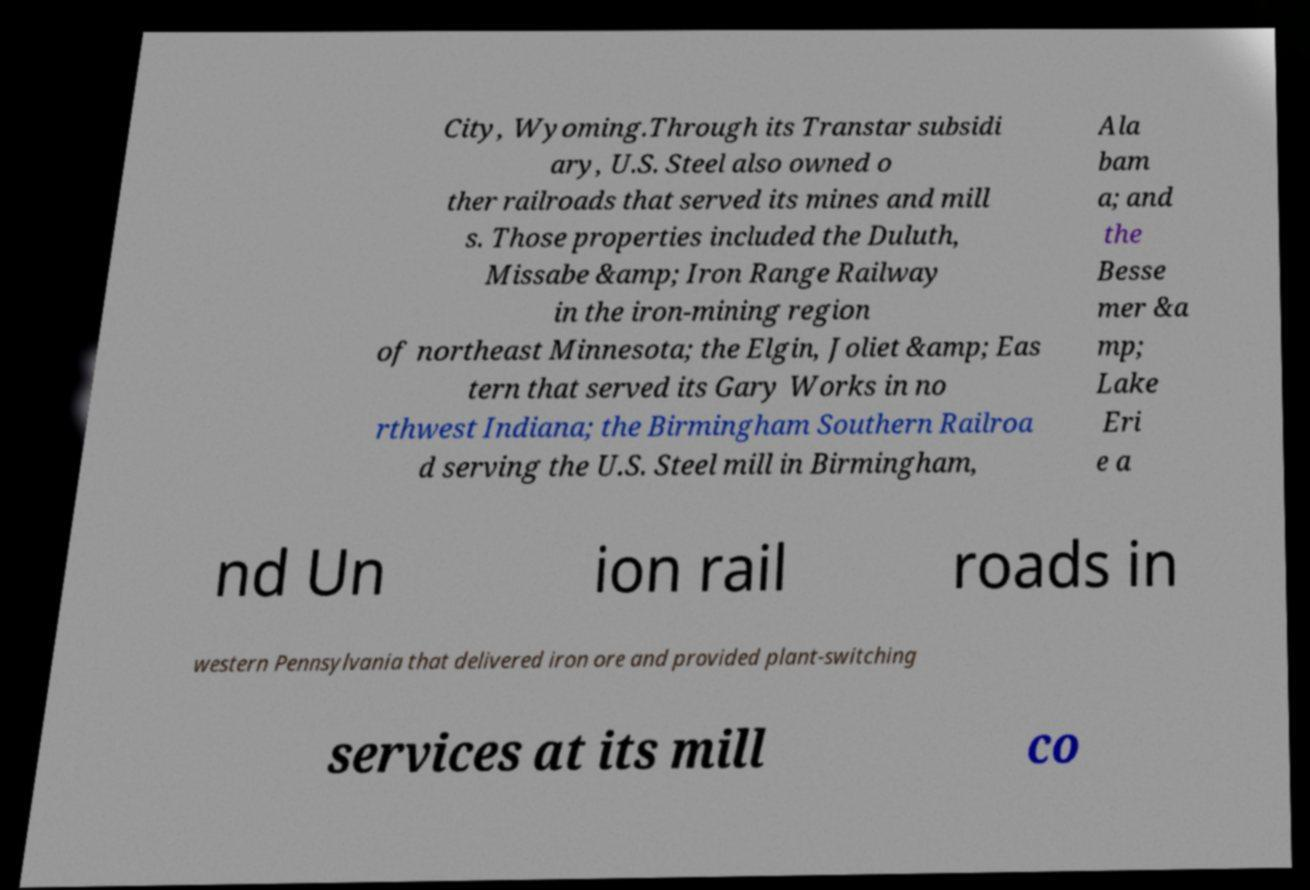Could you extract and type out the text from this image? City, Wyoming.Through its Transtar subsidi ary, U.S. Steel also owned o ther railroads that served its mines and mill s. Those properties included the Duluth, Missabe &amp; Iron Range Railway in the iron-mining region of northeast Minnesota; the Elgin, Joliet &amp; Eas tern that served its Gary Works in no rthwest Indiana; the Birmingham Southern Railroa d serving the U.S. Steel mill in Birmingham, Ala bam a; and the Besse mer &a mp; Lake Eri e a nd Un ion rail roads in western Pennsylvania that delivered iron ore and provided plant-switching services at its mill co 